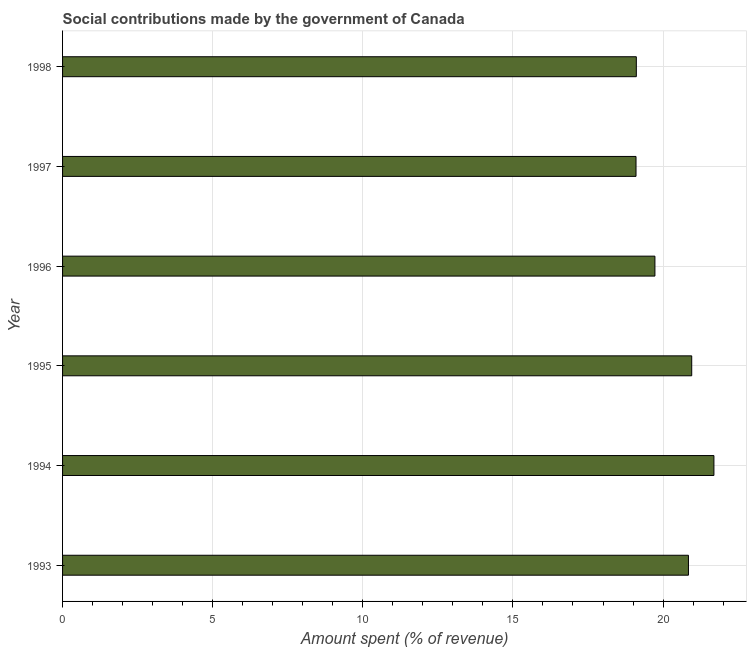What is the title of the graph?
Provide a succinct answer. Social contributions made by the government of Canada. What is the label or title of the X-axis?
Your response must be concise. Amount spent (% of revenue). What is the amount spent in making social contributions in 1994?
Provide a succinct answer. 21.69. Across all years, what is the maximum amount spent in making social contributions?
Keep it short and to the point. 21.69. Across all years, what is the minimum amount spent in making social contributions?
Make the answer very short. 19.1. In which year was the amount spent in making social contributions maximum?
Ensure brevity in your answer.  1994. What is the sum of the amount spent in making social contributions?
Make the answer very short. 121.43. What is the difference between the amount spent in making social contributions in 1995 and 1998?
Give a very brief answer. 1.84. What is the average amount spent in making social contributions per year?
Make the answer very short. 20.24. What is the median amount spent in making social contributions?
Keep it short and to the point. 20.29. Do a majority of the years between 1998 and 1997 (inclusive) have amount spent in making social contributions greater than 7 %?
Make the answer very short. No. What is the ratio of the amount spent in making social contributions in 1993 to that in 1997?
Ensure brevity in your answer.  1.09. What is the difference between the highest and the second highest amount spent in making social contributions?
Make the answer very short. 0.74. Is the sum of the amount spent in making social contributions in 1993 and 1994 greater than the maximum amount spent in making social contributions across all years?
Your answer should be compact. Yes. What is the difference between the highest and the lowest amount spent in making social contributions?
Provide a short and direct response. 2.59. In how many years, is the amount spent in making social contributions greater than the average amount spent in making social contributions taken over all years?
Offer a terse response. 3. How many bars are there?
Provide a succinct answer. 6. What is the difference between two consecutive major ticks on the X-axis?
Provide a short and direct response. 5. What is the Amount spent (% of revenue) of 1993?
Ensure brevity in your answer.  20.85. What is the Amount spent (% of revenue) of 1994?
Ensure brevity in your answer.  21.69. What is the Amount spent (% of revenue) of 1995?
Your answer should be compact. 20.95. What is the Amount spent (% of revenue) of 1996?
Your response must be concise. 19.73. What is the Amount spent (% of revenue) of 1997?
Keep it short and to the point. 19.1. What is the Amount spent (% of revenue) of 1998?
Your response must be concise. 19.11. What is the difference between the Amount spent (% of revenue) in 1993 and 1994?
Provide a succinct answer. -0.85. What is the difference between the Amount spent (% of revenue) in 1993 and 1995?
Your response must be concise. -0.11. What is the difference between the Amount spent (% of revenue) in 1993 and 1996?
Ensure brevity in your answer.  1.12. What is the difference between the Amount spent (% of revenue) in 1993 and 1997?
Give a very brief answer. 1.75. What is the difference between the Amount spent (% of revenue) in 1993 and 1998?
Provide a short and direct response. 1.74. What is the difference between the Amount spent (% of revenue) in 1994 and 1995?
Your response must be concise. 0.74. What is the difference between the Amount spent (% of revenue) in 1994 and 1996?
Give a very brief answer. 1.97. What is the difference between the Amount spent (% of revenue) in 1994 and 1997?
Offer a very short reply. 2.59. What is the difference between the Amount spent (% of revenue) in 1994 and 1998?
Ensure brevity in your answer.  2.58. What is the difference between the Amount spent (% of revenue) in 1995 and 1996?
Make the answer very short. 1.23. What is the difference between the Amount spent (% of revenue) in 1995 and 1997?
Ensure brevity in your answer.  1.86. What is the difference between the Amount spent (% of revenue) in 1995 and 1998?
Provide a short and direct response. 1.85. What is the difference between the Amount spent (% of revenue) in 1996 and 1997?
Your answer should be very brief. 0.63. What is the difference between the Amount spent (% of revenue) in 1996 and 1998?
Give a very brief answer. 0.62. What is the difference between the Amount spent (% of revenue) in 1997 and 1998?
Make the answer very short. -0.01. What is the ratio of the Amount spent (% of revenue) in 1993 to that in 1994?
Your answer should be very brief. 0.96. What is the ratio of the Amount spent (% of revenue) in 1993 to that in 1996?
Give a very brief answer. 1.06. What is the ratio of the Amount spent (% of revenue) in 1993 to that in 1997?
Your response must be concise. 1.09. What is the ratio of the Amount spent (% of revenue) in 1993 to that in 1998?
Offer a terse response. 1.09. What is the ratio of the Amount spent (% of revenue) in 1994 to that in 1995?
Your answer should be very brief. 1.03. What is the ratio of the Amount spent (% of revenue) in 1994 to that in 1996?
Your answer should be very brief. 1.1. What is the ratio of the Amount spent (% of revenue) in 1994 to that in 1997?
Keep it short and to the point. 1.14. What is the ratio of the Amount spent (% of revenue) in 1994 to that in 1998?
Offer a terse response. 1.14. What is the ratio of the Amount spent (% of revenue) in 1995 to that in 1996?
Ensure brevity in your answer.  1.06. What is the ratio of the Amount spent (% of revenue) in 1995 to that in 1997?
Your answer should be very brief. 1.1. What is the ratio of the Amount spent (% of revenue) in 1995 to that in 1998?
Make the answer very short. 1.1. What is the ratio of the Amount spent (% of revenue) in 1996 to that in 1997?
Your answer should be compact. 1.03. What is the ratio of the Amount spent (% of revenue) in 1996 to that in 1998?
Keep it short and to the point. 1.03. 